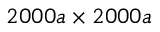<formula> <loc_0><loc_0><loc_500><loc_500>2 0 0 0 a \times 2 0 0 0 a</formula> 